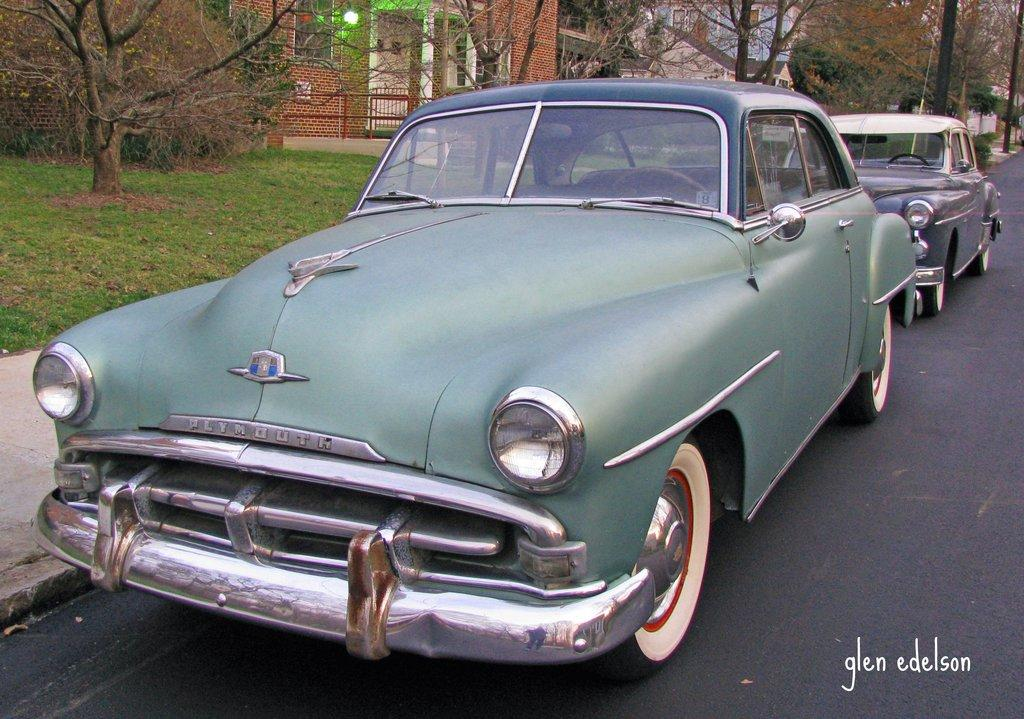How many cars can be seen on the road in the image? There are two cars visible on the road in the image. What is written or displayed at the bottom of the image? There is a text at the bottom of the image. What type of natural elements can be seen at the top of the image? There are trees and a building visible at the top of the image. Can you describe the lighting conditions in the image? There is light visible in the image. What type of barrier is present in the image? There is a fence visible in the image. How many ants can be seen crawling on the cars in the image? There are no ants visible in the image; it only shows two cars on the road. What type of space vehicle is present in the image? There is no space vehicle present in the image; it only shows two cars on the road, trees, a building, and a fence. 